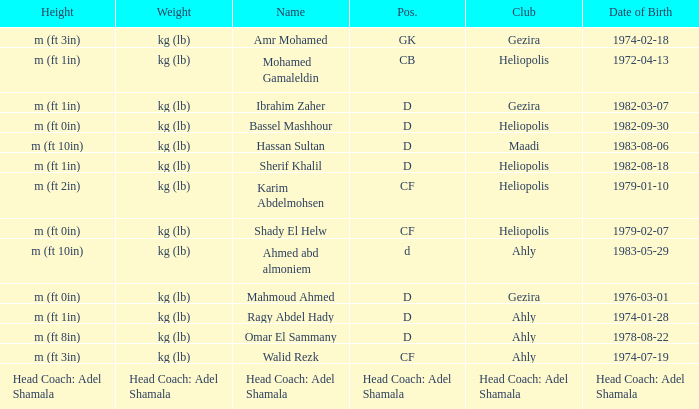What is Name, when Weight is "kg (lb)", when Club is "Gezira", and when Date of Birth is "1974-02-18"? Amr Mohamed. 